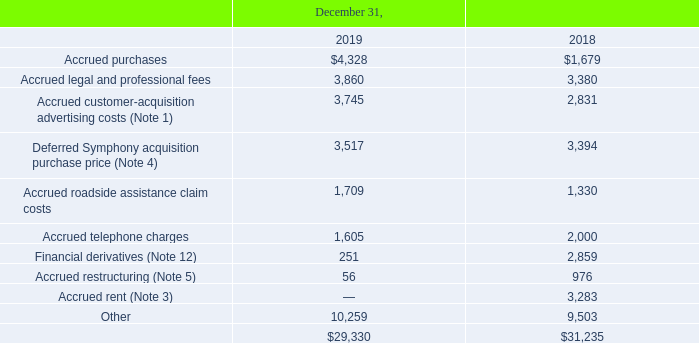Note 17. Other Accrued Expenses and Current Liabilities
Other accrued expenses and current liabilities consisted of the following (in thousands):
What was the amount of Accrued purchases in 2019?
Answer scale should be: thousand. $4,328. What was the amount of Accrued legal and professional fees  in 2018?
Answer scale should be: thousand. 3,380. In which years were the Other accrued expenses and current liabilities calculated? 2019, 2018. In which year were Accrued roadside assistance claim costs larger? 1,709>1,330
Answer: 2019. What was the change in Accrued roadside assistance claim costs in 2019 from 2018?
Answer scale should be: thousand. 1,709-1,330
Answer: 379. What was the percentage change in Accrued roadside assistance claim costs in 2019 from 2018?
Answer scale should be: percent. (1,709-1,330)/1,330
Answer: 28.5. 